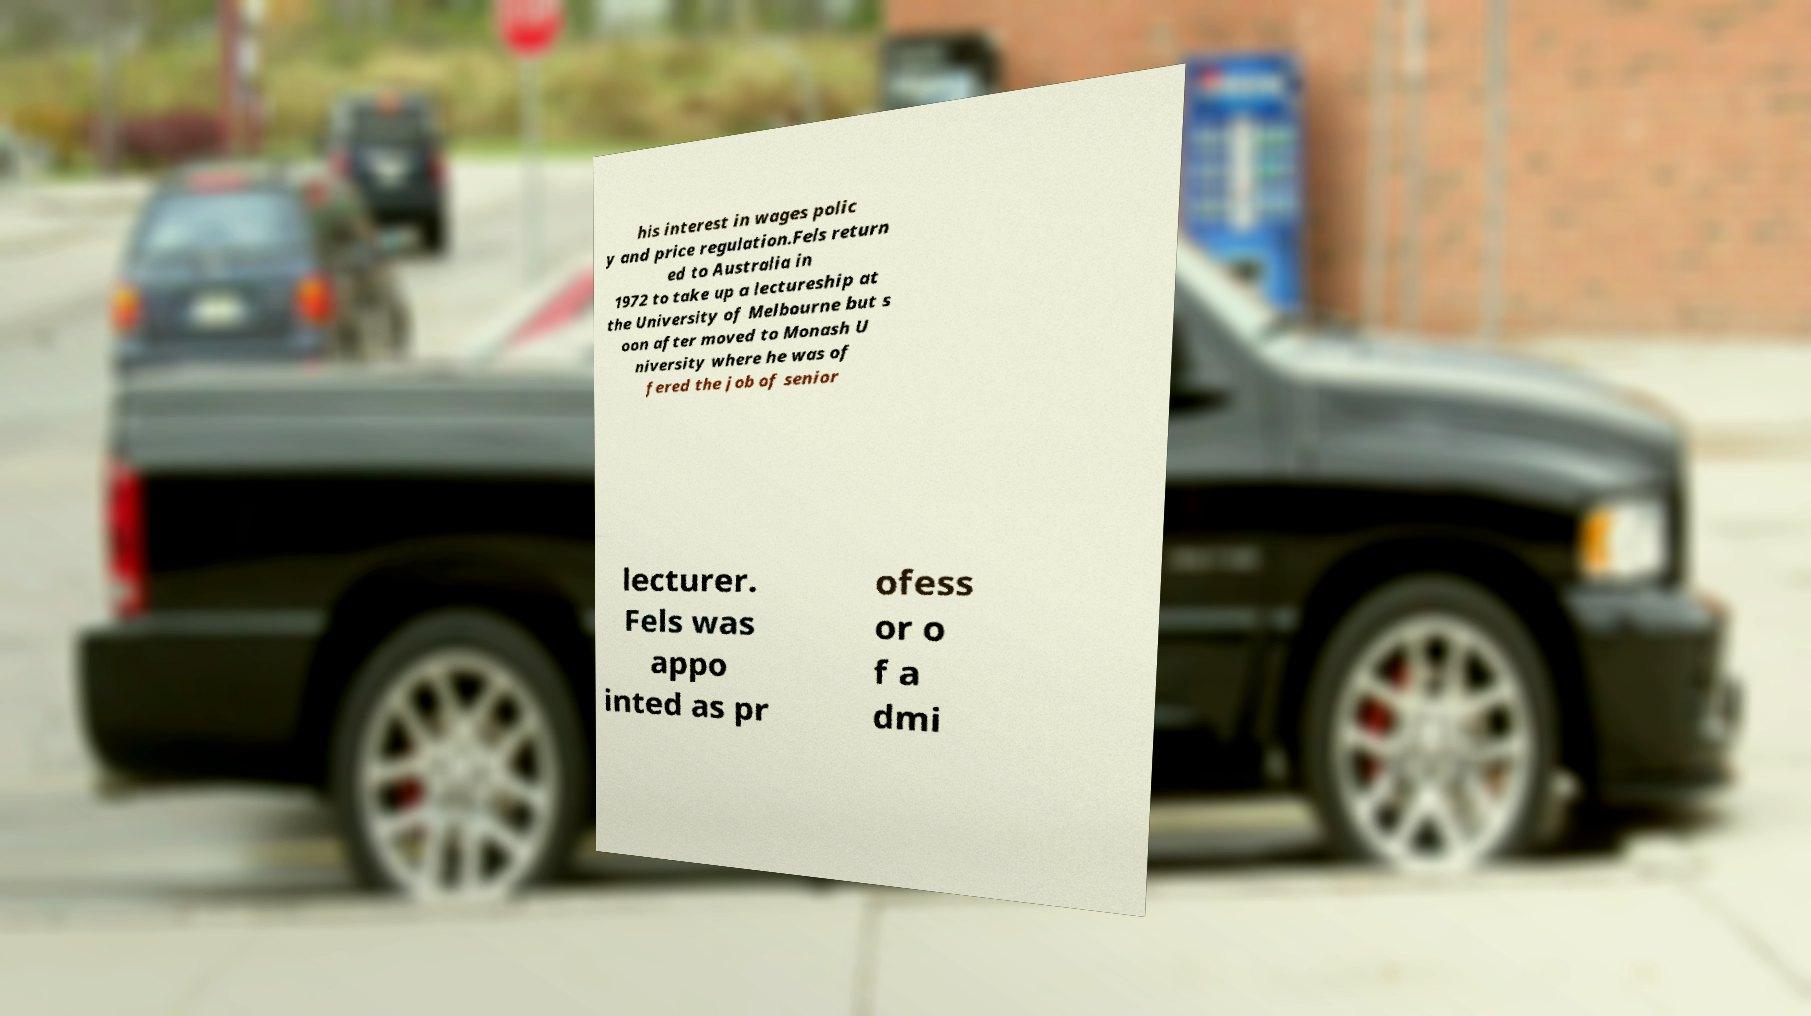I need the written content from this picture converted into text. Can you do that? his interest in wages polic y and price regulation.Fels return ed to Australia in 1972 to take up a lectureship at the University of Melbourne but s oon after moved to Monash U niversity where he was of fered the job of senior lecturer. Fels was appo inted as pr ofess or o f a dmi 